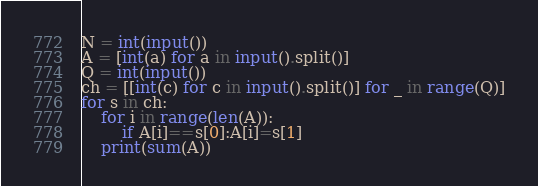<code> <loc_0><loc_0><loc_500><loc_500><_Python_>N = int(input())
A = [int(a) for a in input().split()]
Q = int(input())
ch = [[int(c) for c in input().split()] for _ in range(Q)]
for s in ch:
    for i in range(len(A)):
        if A[i]==s[0]:A[i]=s[1]
    print(sum(A))</code> 